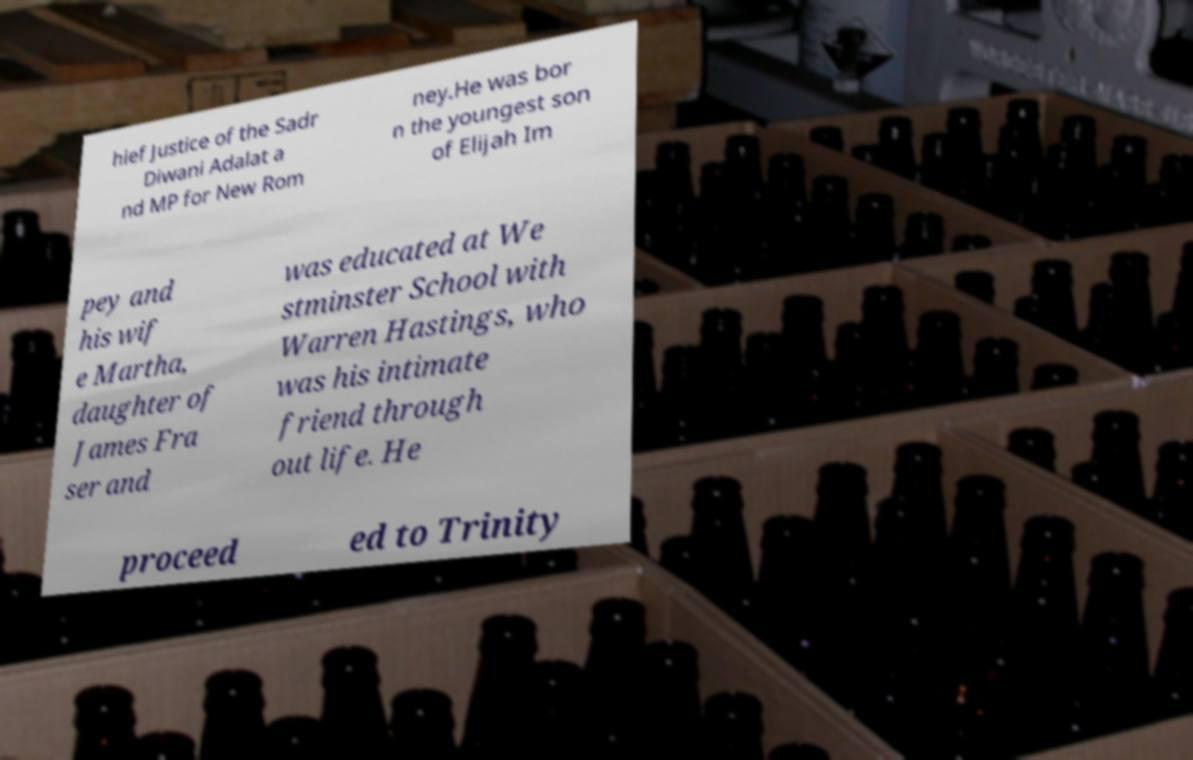There's text embedded in this image that I need extracted. Can you transcribe it verbatim? hief Justice of the Sadr Diwani Adalat a nd MP for New Rom ney.He was bor n the youngest son of Elijah Im pey and his wif e Martha, daughter of James Fra ser and was educated at We stminster School with Warren Hastings, who was his intimate friend through out life. He proceed ed to Trinity 